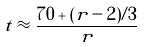<formula> <loc_0><loc_0><loc_500><loc_500>t \approx \frac { 7 0 + ( r - 2 ) / 3 } { r }</formula> 